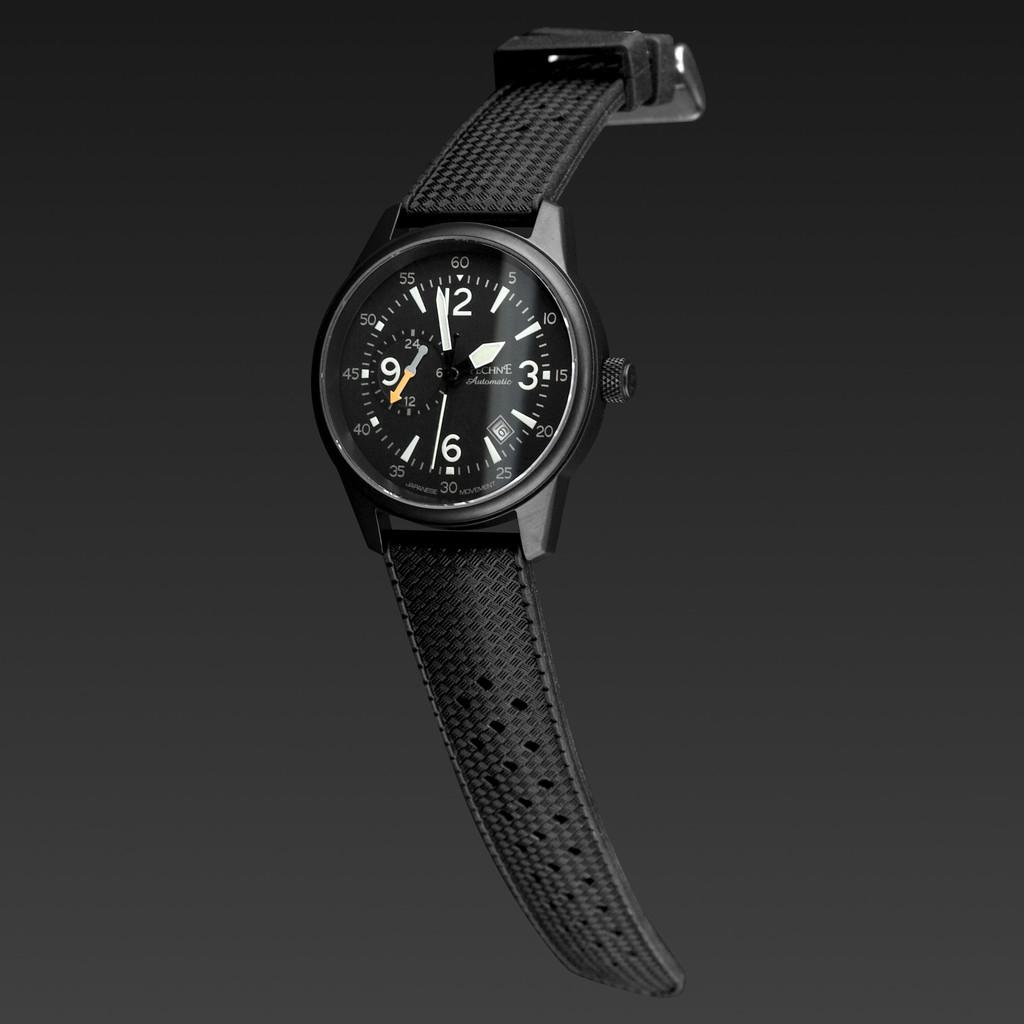<image>
Relay a brief, clear account of the picture shown. A black watch says "Automatic" on the face. 